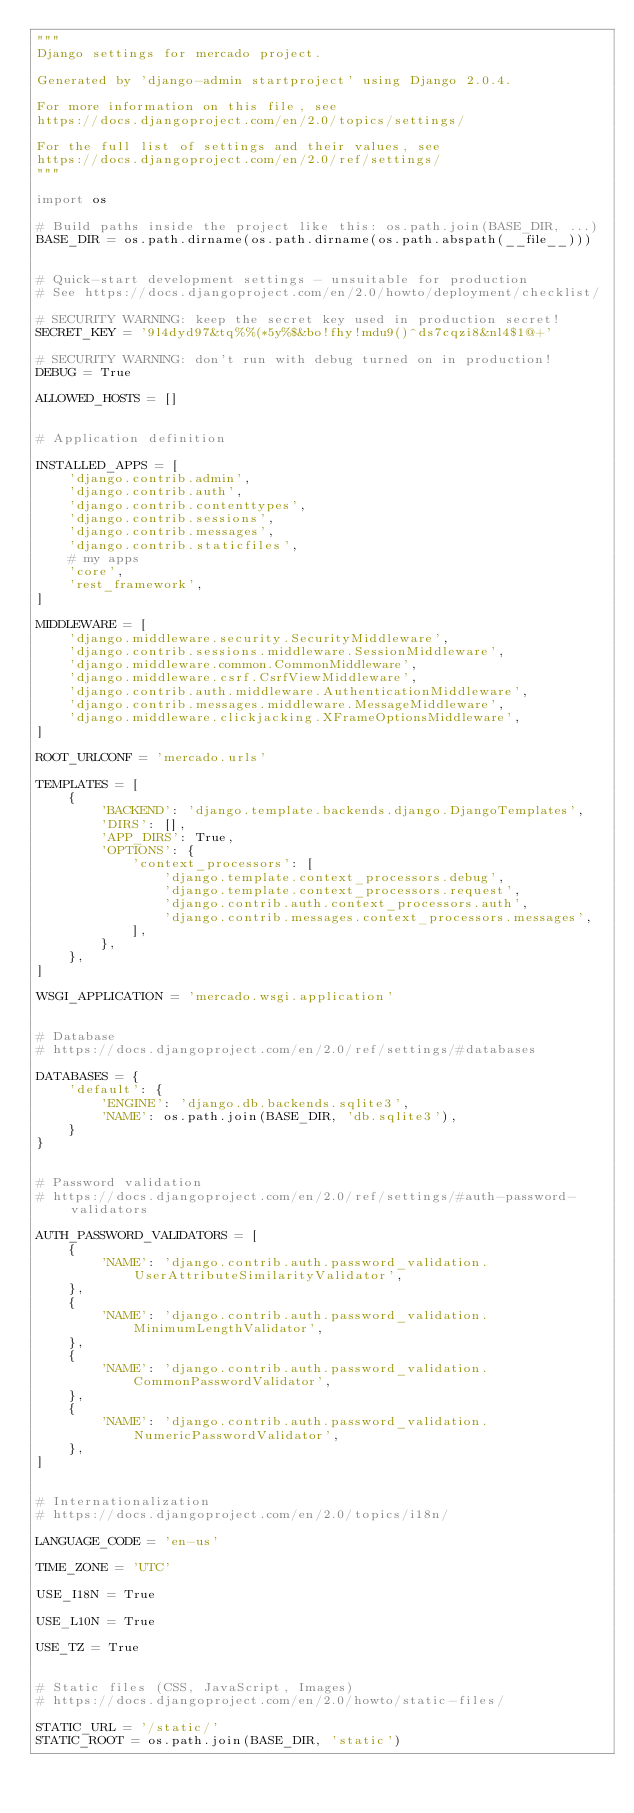<code> <loc_0><loc_0><loc_500><loc_500><_Python_>"""
Django settings for mercado project.

Generated by 'django-admin startproject' using Django 2.0.4.

For more information on this file, see
https://docs.djangoproject.com/en/2.0/topics/settings/

For the full list of settings and their values, see
https://docs.djangoproject.com/en/2.0/ref/settings/
"""

import os

# Build paths inside the project like this: os.path.join(BASE_DIR, ...)
BASE_DIR = os.path.dirname(os.path.dirname(os.path.abspath(__file__)))


# Quick-start development settings - unsuitable for production
# See https://docs.djangoproject.com/en/2.0/howto/deployment/checklist/

# SECURITY WARNING: keep the secret key used in production secret!
SECRET_KEY = '9l4dyd97&tq%%(*5y%$&bo!fhy!mdu9()^ds7cqzi8&nl4$1@+'

# SECURITY WARNING: don't run with debug turned on in production!
DEBUG = True

ALLOWED_HOSTS = []


# Application definition

INSTALLED_APPS = [
    'django.contrib.admin',
    'django.contrib.auth',
    'django.contrib.contenttypes',
    'django.contrib.sessions',
    'django.contrib.messages',
    'django.contrib.staticfiles',
    # my apps
    'core',
    'rest_framework',
]

MIDDLEWARE = [
    'django.middleware.security.SecurityMiddleware',
    'django.contrib.sessions.middleware.SessionMiddleware',
    'django.middleware.common.CommonMiddleware',
    'django.middleware.csrf.CsrfViewMiddleware',
    'django.contrib.auth.middleware.AuthenticationMiddleware',
    'django.contrib.messages.middleware.MessageMiddleware',
    'django.middleware.clickjacking.XFrameOptionsMiddleware',
]

ROOT_URLCONF = 'mercado.urls'

TEMPLATES = [
    {
        'BACKEND': 'django.template.backends.django.DjangoTemplates',
        'DIRS': [],
        'APP_DIRS': True,
        'OPTIONS': {
            'context_processors': [
                'django.template.context_processors.debug',
                'django.template.context_processors.request',
                'django.contrib.auth.context_processors.auth',
                'django.contrib.messages.context_processors.messages',
            ],
        },
    },
]

WSGI_APPLICATION = 'mercado.wsgi.application'


# Database
# https://docs.djangoproject.com/en/2.0/ref/settings/#databases

DATABASES = {
    'default': {
        'ENGINE': 'django.db.backends.sqlite3',
        'NAME': os.path.join(BASE_DIR, 'db.sqlite3'),
    }
}


# Password validation
# https://docs.djangoproject.com/en/2.0/ref/settings/#auth-password-validators

AUTH_PASSWORD_VALIDATORS = [
    {
        'NAME': 'django.contrib.auth.password_validation.UserAttributeSimilarityValidator',
    },
    {
        'NAME': 'django.contrib.auth.password_validation.MinimumLengthValidator',
    },
    {
        'NAME': 'django.contrib.auth.password_validation.CommonPasswordValidator',
    },
    {
        'NAME': 'django.contrib.auth.password_validation.NumericPasswordValidator',
    },
]


# Internationalization
# https://docs.djangoproject.com/en/2.0/topics/i18n/

LANGUAGE_CODE = 'en-us'

TIME_ZONE = 'UTC'

USE_I18N = True

USE_L10N = True

USE_TZ = True


# Static files (CSS, JavaScript, Images)
# https://docs.djangoproject.com/en/2.0/howto/static-files/

STATIC_URL = '/static/'
STATIC_ROOT = os.path.join(BASE_DIR, 'static')</code> 